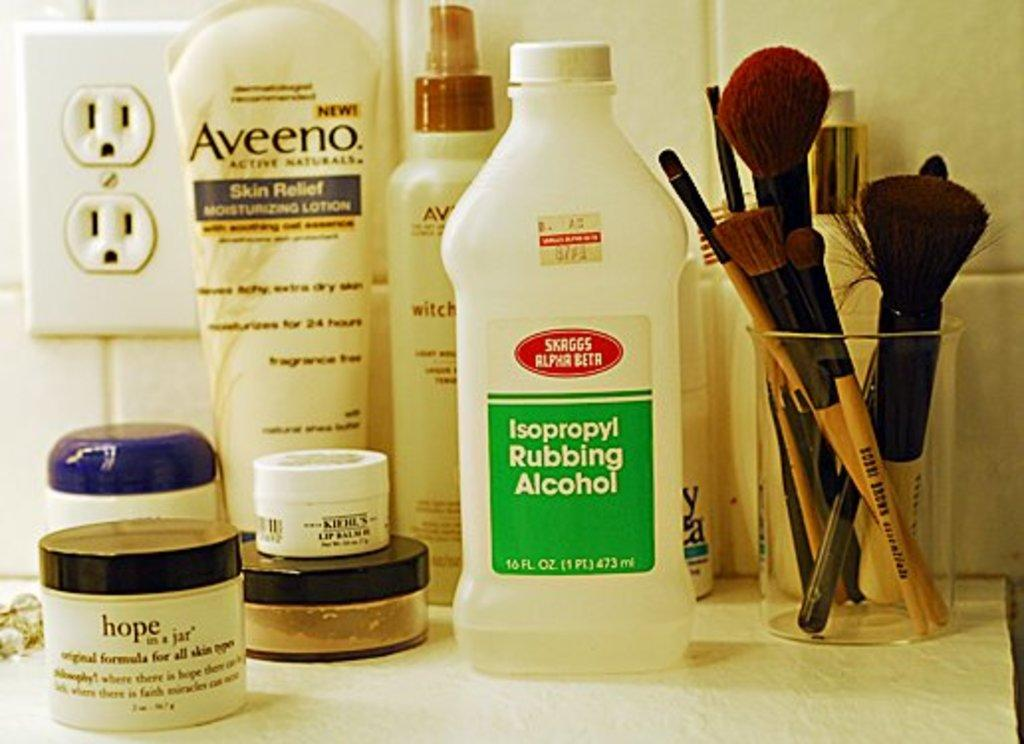<image>
Present a compact description of the photo's key features. counter with bottle of rubbing alcohol, tube of aveeno, other small jars and cup with makeup brushes 